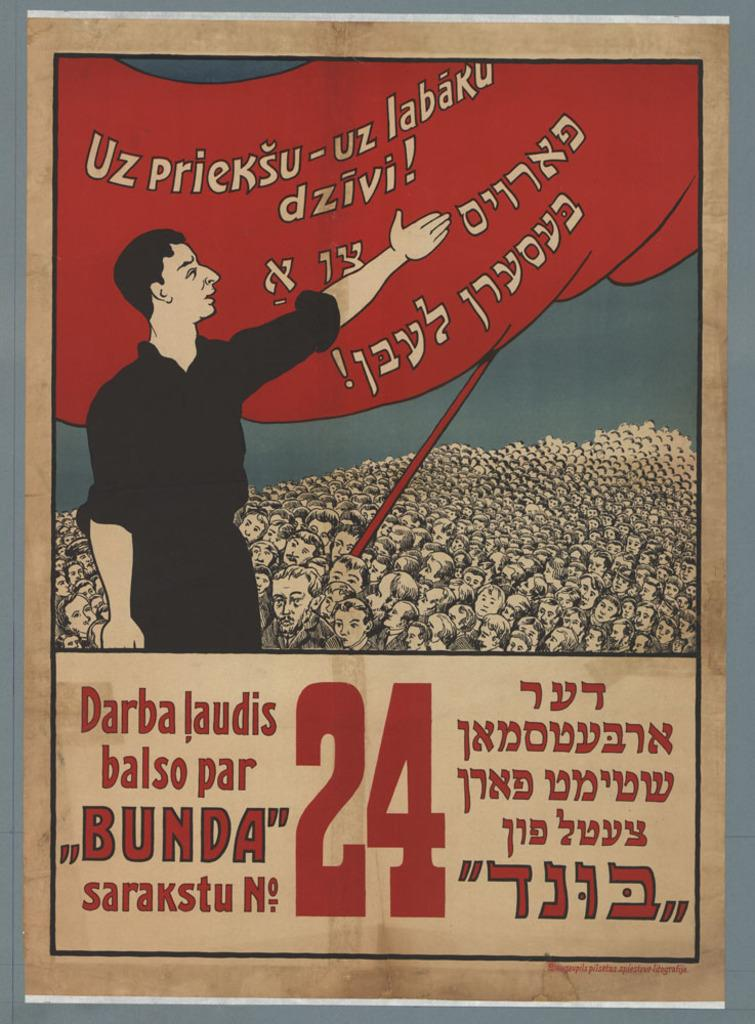What is the main subject of the picture? The main subject of the picture is an image of a person. Are there any other elements in the picture besides the person? Yes, there is text in the picture. What type of war is being advertised in the image? There is no war or advertisement present in the image; it features an image of a person and text. What kind of apparatus is being used by the person in the image? There is no apparatus visible in the image; it only shows a person and text. 